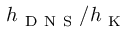<formula> <loc_0><loc_0><loc_500><loc_500>h _ { D N S } / h _ { K }</formula> 